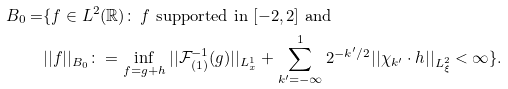Convert formula to latex. <formula><loc_0><loc_0><loc_500><loc_500>B _ { 0 } = & \{ f \in L ^ { 2 } ( \mathbb { R } ) \colon \, f \text { supported in } [ - 2 , 2 ] \text { and } \\ & | | f | | _ { B _ { 0 } } \colon = \inf _ { f = g + h } | | \mathcal { F } _ { ( 1 ) } ^ { - 1 } ( g ) | | _ { L ^ { 1 } _ { x } } + \sum _ { k ^ { \prime } = - \infty } ^ { 1 } 2 ^ { - k ^ { \prime } / 2 } | | \chi _ { k ^ { \prime } } \cdot h | | _ { L ^ { 2 } _ { \xi } } < \infty \} .</formula> 